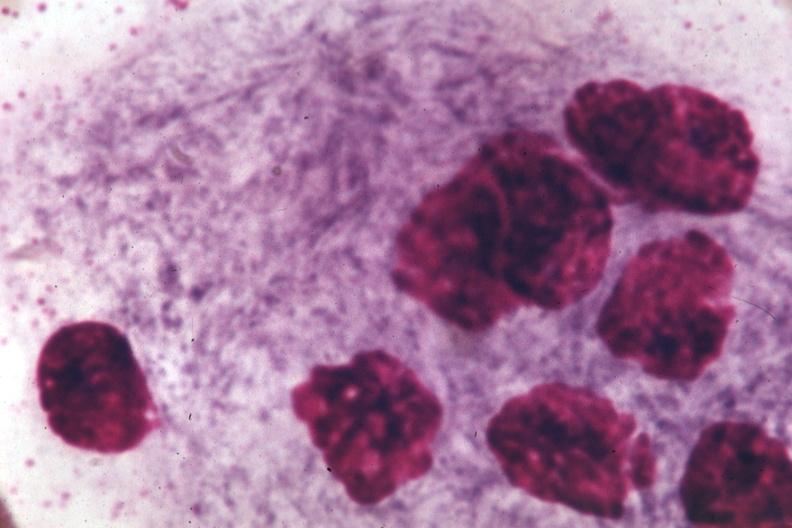what is present?
Answer the question using a single word or phrase. Gaucher cell 